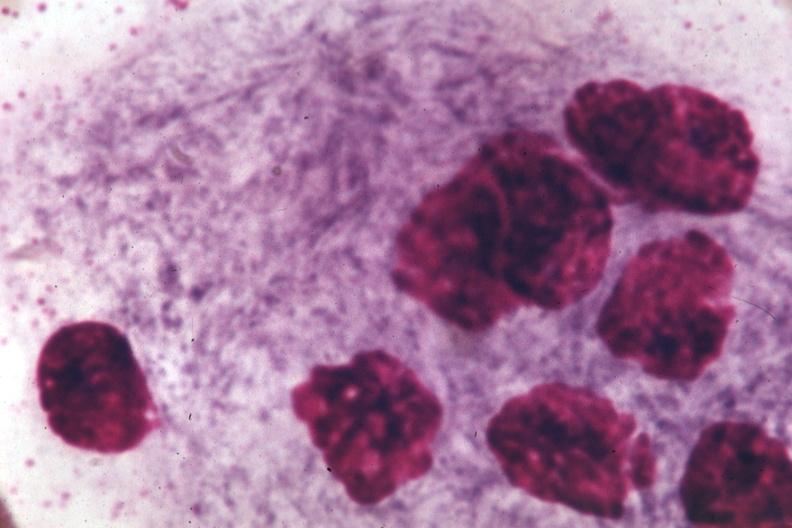what is present?
Answer the question using a single word or phrase. Gaucher cell 